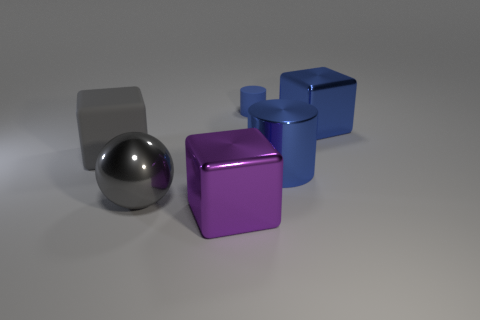Subtract all big purple cubes. How many cubes are left? 2 Subtract 1 balls. How many balls are left? 0 Add 4 large metal objects. How many objects exist? 10 Subtract all balls. How many objects are left? 5 Add 4 rubber blocks. How many rubber blocks exist? 5 Subtract all gray blocks. How many blocks are left? 2 Subtract 1 blue cubes. How many objects are left? 5 Subtract all red cubes. Subtract all purple cylinders. How many cubes are left? 3 Subtract all gray balls. How many gray blocks are left? 1 Subtract all blue matte things. Subtract all big metallic cubes. How many objects are left? 3 